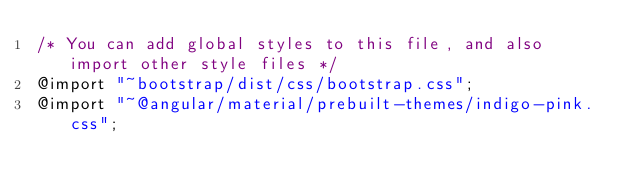<code> <loc_0><loc_0><loc_500><loc_500><_CSS_>/* You can add global styles to this file, and also import other style files */
@import "~bootstrap/dist/css/bootstrap.css";
@import "~@angular/material/prebuilt-themes/indigo-pink.css";</code> 